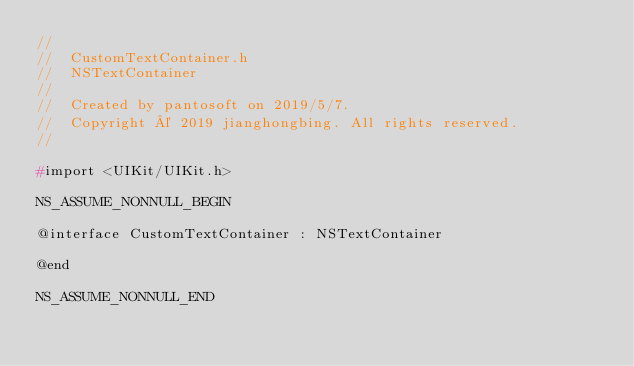Convert code to text. <code><loc_0><loc_0><loc_500><loc_500><_C_>//
//  CustomTextContainer.h
//  NSTextContainer
//
//  Created by pantosoft on 2019/5/7.
//  Copyright © 2019 jianghongbing. All rights reserved.
//

#import <UIKit/UIKit.h>

NS_ASSUME_NONNULL_BEGIN

@interface CustomTextContainer : NSTextContainer

@end

NS_ASSUME_NONNULL_END
</code> 